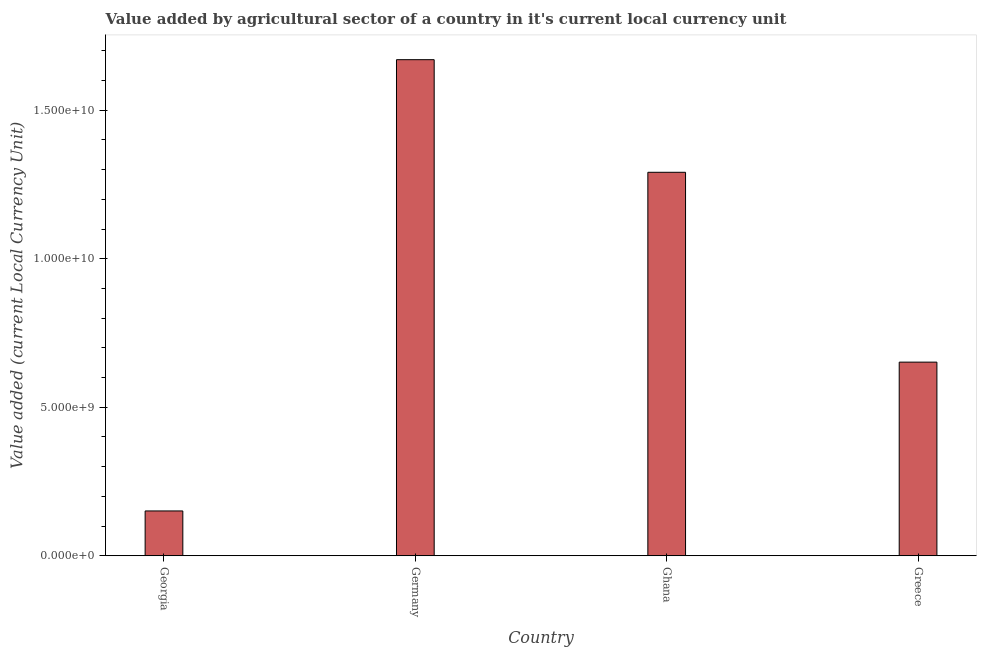What is the title of the graph?
Make the answer very short. Value added by agricultural sector of a country in it's current local currency unit. What is the label or title of the X-axis?
Your response must be concise. Country. What is the label or title of the Y-axis?
Your response must be concise. Value added (current Local Currency Unit). What is the value added by agriculture sector in Greece?
Your answer should be compact. 6.52e+09. Across all countries, what is the maximum value added by agriculture sector?
Ensure brevity in your answer.  1.67e+1. Across all countries, what is the minimum value added by agriculture sector?
Ensure brevity in your answer.  1.51e+09. In which country was the value added by agriculture sector maximum?
Give a very brief answer. Germany. In which country was the value added by agriculture sector minimum?
Your answer should be compact. Georgia. What is the sum of the value added by agriculture sector?
Make the answer very short. 3.76e+1. What is the difference between the value added by agriculture sector in Germany and Greece?
Give a very brief answer. 1.02e+1. What is the average value added by agriculture sector per country?
Your answer should be compact. 9.41e+09. What is the median value added by agriculture sector?
Provide a succinct answer. 9.71e+09. What is the ratio of the value added by agriculture sector in Germany to that in Greece?
Keep it short and to the point. 2.56. Is the value added by agriculture sector in Germany less than that in Ghana?
Give a very brief answer. No. Is the difference between the value added by agriculture sector in Germany and Greece greater than the difference between any two countries?
Offer a very short reply. No. What is the difference between the highest and the second highest value added by agriculture sector?
Offer a very short reply. 3.79e+09. Is the sum of the value added by agriculture sector in Germany and Greece greater than the maximum value added by agriculture sector across all countries?
Keep it short and to the point. Yes. What is the difference between the highest and the lowest value added by agriculture sector?
Offer a terse response. 1.52e+1. Are all the bars in the graph horizontal?
Your answer should be compact. No. What is the difference between two consecutive major ticks on the Y-axis?
Keep it short and to the point. 5.00e+09. Are the values on the major ticks of Y-axis written in scientific E-notation?
Keep it short and to the point. Yes. What is the Value added (current Local Currency Unit) in Georgia?
Provide a short and direct response. 1.51e+09. What is the Value added (current Local Currency Unit) of Germany?
Your answer should be very brief. 1.67e+1. What is the Value added (current Local Currency Unit) in Ghana?
Keep it short and to the point. 1.29e+1. What is the Value added (current Local Currency Unit) of Greece?
Offer a very short reply. 6.52e+09. What is the difference between the Value added (current Local Currency Unit) in Georgia and Germany?
Provide a short and direct response. -1.52e+1. What is the difference between the Value added (current Local Currency Unit) in Georgia and Ghana?
Your answer should be very brief. -1.14e+1. What is the difference between the Value added (current Local Currency Unit) in Georgia and Greece?
Your answer should be very brief. -5.01e+09. What is the difference between the Value added (current Local Currency Unit) in Germany and Ghana?
Your answer should be very brief. 3.79e+09. What is the difference between the Value added (current Local Currency Unit) in Germany and Greece?
Provide a short and direct response. 1.02e+1. What is the difference between the Value added (current Local Currency Unit) in Ghana and Greece?
Your answer should be very brief. 6.39e+09. What is the ratio of the Value added (current Local Currency Unit) in Georgia to that in Germany?
Keep it short and to the point. 0.09. What is the ratio of the Value added (current Local Currency Unit) in Georgia to that in Ghana?
Your response must be concise. 0.12. What is the ratio of the Value added (current Local Currency Unit) in Georgia to that in Greece?
Offer a very short reply. 0.23. What is the ratio of the Value added (current Local Currency Unit) in Germany to that in Ghana?
Your answer should be very brief. 1.29. What is the ratio of the Value added (current Local Currency Unit) in Germany to that in Greece?
Provide a short and direct response. 2.56. What is the ratio of the Value added (current Local Currency Unit) in Ghana to that in Greece?
Provide a succinct answer. 1.98. 